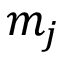<formula> <loc_0><loc_0><loc_500><loc_500>m _ { j }</formula> 